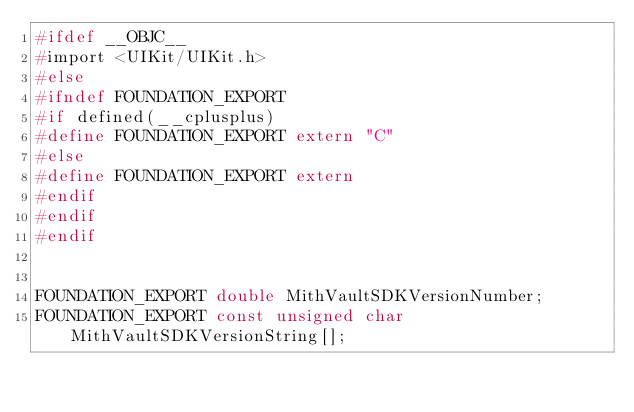Convert code to text. <code><loc_0><loc_0><loc_500><loc_500><_C_>#ifdef __OBJC__
#import <UIKit/UIKit.h>
#else
#ifndef FOUNDATION_EXPORT
#if defined(__cplusplus)
#define FOUNDATION_EXPORT extern "C"
#else
#define FOUNDATION_EXPORT extern
#endif
#endif
#endif


FOUNDATION_EXPORT double MithVaultSDKVersionNumber;
FOUNDATION_EXPORT const unsigned char MithVaultSDKVersionString[];

</code> 